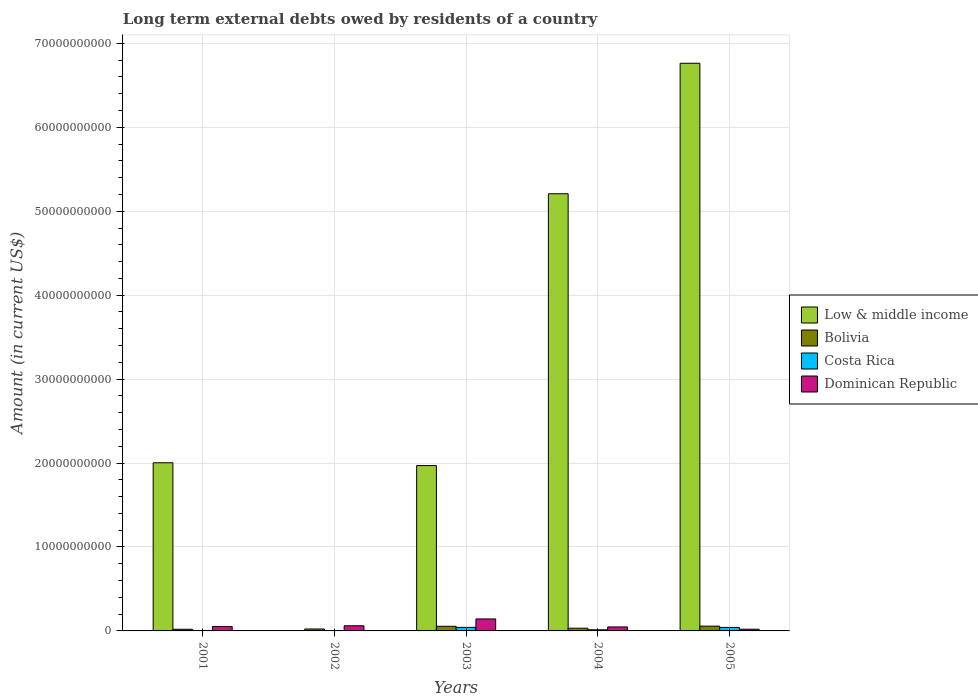How many different coloured bars are there?
Your answer should be very brief. 4. Are the number of bars per tick equal to the number of legend labels?
Your answer should be very brief. No. Are the number of bars on each tick of the X-axis equal?
Make the answer very short. No. What is the label of the 1st group of bars from the left?
Provide a short and direct response. 2001. What is the amount of long-term external debts owed by residents in Bolivia in 2005?
Your response must be concise. 5.71e+08. Across all years, what is the maximum amount of long-term external debts owed by residents in Bolivia?
Your answer should be compact. 5.71e+08. Across all years, what is the minimum amount of long-term external debts owed by residents in Dominican Republic?
Offer a very short reply. 2.03e+08. In which year was the amount of long-term external debts owed by residents in Low & middle income maximum?
Ensure brevity in your answer.  2005. What is the total amount of long-term external debts owed by residents in Bolivia in the graph?
Provide a short and direct response. 1.87e+09. What is the difference between the amount of long-term external debts owed by residents in Dominican Republic in 2001 and that in 2004?
Make the answer very short. 5.07e+07. What is the difference between the amount of long-term external debts owed by residents in Bolivia in 2003 and the amount of long-term external debts owed by residents in Costa Rica in 2004?
Give a very brief answer. 4.18e+08. What is the average amount of long-term external debts owed by residents in Bolivia per year?
Your answer should be very brief. 3.74e+08. In the year 2003, what is the difference between the amount of long-term external debts owed by residents in Low & middle income and amount of long-term external debts owed by residents in Dominican Republic?
Your answer should be very brief. 1.83e+1. What is the ratio of the amount of long-term external debts owed by residents in Low & middle income in 2001 to that in 2004?
Give a very brief answer. 0.38. What is the difference between the highest and the second highest amount of long-term external debts owed by residents in Costa Rica?
Ensure brevity in your answer.  6.95e+06. What is the difference between the highest and the lowest amount of long-term external debts owed by residents in Low & middle income?
Give a very brief answer. 6.76e+1. In how many years, is the amount of long-term external debts owed by residents in Costa Rica greater than the average amount of long-term external debts owed by residents in Costa Rica taken over all years?
Make the answer very short. 2. Is the sum of the amount of long-term external debts owed by residents in Dominican Republic in 2003 and 2004 greater than the maximum amount of long-term external debts owed by residents in Low & middle income across all years?
Your answer should be very brief. No. Is it the case that in every year, the sum of the amount of long-term external debts owed by residents in Bolivia and amount of long-term external debts owed by residents in Costa Rica is greater than the sum of amount of long-term external debts owed by residents in Dominican Republic and amount of long-term external debts owed by residents in Low & middle income?
Ensure brevity in your answer.  No. Are all the bars in the graph horizontal?
Offer a very short reply. No. What is the difference between two consecutive major ticks on the Y-axis?
Offer a terse response. 1.00e+1. Are the values on the major ticks of Y-axis written in scientific E-notation?
Offer a very short reply. No. What is the title of the graph?
Your response must be concise. Long term external debts owed by residents of a country. Does "Europe(all income levels)" appear as one of the legend labels in the graph?
Your answer should be very brief. No. What is the label or title of the X-axis?
Give a very brief answer. Years. What is the Amount (in current US$) in Low & middle income in 2001?
Your answer should be compact. 2.00e+1. What is the Amount (in current US$) in Bolivia in 2001?
Your answer should be very brief. 1.96e+08. What is the Amount (in current US$) in Costa Rica in 2001?
Offer a terse response. 2.68e+07. What is the Amount (in current US$) in Dominican Republic in 2001?
Make the answer very short. 5.24e+08. What is the Amount (in current US$) in Low & middle income in 2002?
Offer a very short reply. 0. What is the Amount (in current US$) of Bolivia in 2002?
Offer a terse response. 2.30e+08. What is the Amount (in current US$) of Costa Rica in 2002?
Keep it short and to the point. 0. What is the Amount (in current US$) in Dominican Republic in 2002?
Provide a short and direct response. 6.15e+08. What is the Amount (in current US$) in Low & middle income in 2003?
Provide a succinct answer. 1.97e+1. What is the Amount (in current US$) of Bolivia in 2003?
Offer a terse response. 5.53e+08. What is the Amount (in current US$) of Costa Rica in 2003?
Provide a succinct answer. 4.24e+08. What is the Amount (in current US$) in Dominican Republic in 2003?
Ensure brevity in your answer.  1.43e+09. What is the Amount (in current US$) in Low & middle income in 2004?
Offer a very short reply. 5.21e+1. What is the Amount (in current US$) of Bolivia in 2004?
Your answer should be compact. 3.22e+08. What is the Amount (in current US$) of Costa Rica in 2004?
Offer a terse response. 1.35e+08. What is the Amount (in current US$) of Dominican Republic in 2004?
Provide a succinct answer. 4.73e+08. What is the Amount (in current US$) of Low & middle income in 2005?
Keep it short and to the point. 6.76e+1. What is the Amount (in current US$) in Bolivia in 2005?
Provide a succinct answer. 5.71e+08. What is the Amount (in current US$) of Costa Rica in 2005?
Ensure brevity in your answer.  4.17e+08. What is the Amount (in current US$) in Dominican Republic in 2005?
Provide a short and direct response. 2.03e+08. Across all years, what is the maximum Amount (in current US$) in Low & middle income?
Keep it short and to the point. 6.76e+1. Across all years, what is the maximum Amount (in current US$) in Bolivia?
Make the answer very short. 5.71e+08. Across all years, what is the maximum Amount (in current US$) of Costa Rica?
Keep it short and to the point. 4.24e+08. Across all years, what is the maximum Amount (in current US$) of Dominican Republic?
Keep it short and to the point. 1.43e+09. Across all years, what is the minimum Amount (in current US$) in Bolivia?
Offer a very short reply. 1.96e+08. Across all years, what is the minimum Amount (in current US$) of Costa Rica?
Your answer should be very brief. 0. Across all years, what is the minimum Amount (in current US$) in Dominican Republic?
Offer a terse response. 2.03e+08. What is the total Amount (in current US$) of Low & middle income in the graph?
Your response must be concise. 1.59e+11. What is the total Amount (in current US$) in Bolivia in the graph?
Your response must be concise. 1.87e+09. What is the total Amount (in current US$) of Costa Rica in the graph?
Your answer should be compact. 1.00e+09. What is the total Amount (in current US$) of Dominican Republic in the graph?
Ensure brevity in your answer.  3.24e+09. What is the difference between the Amount (in current US$) in Bolivia in 2001 and that in 2002?
Keep it short and to the point. -3.35e+07. What is the difference between the Amount (in current US$) of Dominican Republic in 2001 and that in 2002?
Your answer should be very brief. -9.15e+07. What is the difference between the Amount (in current US$) in Low & middle income in 2001 and that in 2003?
Offer a terse response. 3.35e+08. What is the difference between the Amount (in current US$) of Bolivia in 2001 and that in 2003?
Give a very brief answer. -3.56e+08. What is the difference between the Amount (in current US$) in Costa Rica in 2001 and that in 2003?
Offer a very short reply. -3.97e+08. What is the difference between the Amount (in current US$) in Dominican Republic in 2001 and that in 2003?
Provide a short and direct response. -9.02e+08. What is the difference between the Amount (in current US$) of Low & middle income in 2001 and that in 2004?
Your answer should be compact. -3.20e+1. What is the difference between the Amount (in current US$) in Bolivia in 2001 and that in 2004?
Your answer should be compact. -1.26e+08. What is the difference between the Amount (in current US$) of Costa Rica in 2001 and that in 2004?
Ensure brevity in your answer.  -1.08e+08. What is the difference between the Amount (in current US$) in Dominican Republic in 2001 and that in 2004?
Keep it short and to the point. 5.07e+07. What is the difference between the Amount (in current US$) in Low & middle income in 2001 and that in 2005?
Offer a very short reply. -4.76e+1. What is the difference between the Amount (in current US$) in Bolivia in 2001 and that in 2005?
Give a very brief answer. -3.75e+08. What is the difference between the Amount (in current US$) in Costa Rica in 2001 and that in 2005?
Provide a short and direct response. -3.90e+08. What is the difference between the Amount (in current US$) of Dominican Republic in 2001 and that in 2005?
Keep it short and to the point. 3.21e+08. What is the difference between the Amount (in current US$) of Bolivia in 2002 and that in 2003?
Ensure brevity in your answer.  -3.23e+08. What is the difference between the Amount (in current US$) in Dominican Republic in 2002 and that in 2003?
Your answer should be very brief. -8.11e+08. What is the difference between the Amount (in current US$) of Bolivia in 2002 and that in 2004?
Your answer should be compact. -9.23e+07. What is the difference between the Amount (in current US$) in Dominican Republic in 2002 and that in 2004?
Make the answer very short. 1.42e+08. What is the difference between the Amount (in current US$) of Bolivia in 2002 and that in 2005?
Your answer should be very brief. -3.41e+08. What is the difference between the Amount (in current US$) of Dominican Republic in 2002 and that in 2005?
Ensure brevity in your answer.  4.12e+08. What is the difference between the Amount (in current US$) in Low & middle income in 2003 and that in 2004?
Offer a terse response. -3.24e+1. What is the difference between the Amount (in current US$) of Bolivia in 2003 and that in 2004?
Make the answer very short. 2.31e+08. What is the difference between the Amount (in current US$) of Costa Rica in 2003 and that in 2004?
Provide a short and direct response. 2.89e+08. What is the difference between the Amount (in current US$) of Dominican Republic in 2003 and that in 2004?
Provide a short and direct response. 9.53e+08. What is the difference between the Amount (in current US$) in Low & middle income in 2003 and that in 2005?
Keep it short and to the point. -4.79e+1. What is the difference between the Amount (in current US$) in Bolivia in 2003 and that in 2005?
Make the answer very short. -1.83e+07. What is the difference between the Amount (in current US$) in Costa Rica in 2003 and that in 2005?
Provide a succinct answer. 6.95e+06. What is the difference between the Amount (in current US$) of Dominican Republic in 2003 and that in 2005?
Make the answer very short. 1.22e+09. What is the difference between the Amount (in current US$) in Low & middle income in 2004 and that in 2005?
Your answer should be compact. -1.55e+1. What is the difference between the Amount (in current US$) of Bolivia in 2004 and that in 2005?
Offer a terse response. -2.49e+08. What is the difference between the Amount (in current US$) in Costa Rica in 2004 and that in 2005?
Provide a succinct answer. -2.82e+08. What is the difference between the Amount (in current US$) in Dominican Republic in 2004 and that in 2005?
Make the answer very short. 2.70e+08. What is the difference between the Amount (in current US$) of Low & middle income in 2001 and the Amount (in current US$) of Bolivia in 2002?
Your answer should be very brief. 1.98e+1. What is the difference between the Amount (in current US$) in Low & middle income in 2001 and the Amount (in current US$) in Dominican Republic in 2002?
Ensure brevity in your answer.  1.94e+1. What is the difference between the Amount (in current US$) in Bolivia in 2001 and the Amount (in current US$) in Dominican Republic in 2002?
Offer a very short reply. -4.19e+08. What is the difference between the Amount (in current US$) in Costa Rica in 2001 and the Amount (in current US$) in Dominican Republic in 2002?
Your response must be concise. -5.89e+08. What is the difference between the Amount (in current US$) of Low & middle income in 2001 and the Amount (in current US$) of Bolivia in 2003?
Your answer should be compact. 1.95e+1. What is the difference between the Amount (in current US$) of Low & middle income in 2001 and the Amount (in current US$) of Costa Rica in 2003?
Your answer should be very brief. 1.96e+1. What is the difference between the Amount (in current US$) of Low & middle income in 2001 and the Amount (in current US$) of Dominican Republic in 2003?
Keep it short and to the point. 1.86e+1. What is the difference between the Amount (in current US$) in Bolivia in 2001 and the Amount (in current US$) in Costa Rica in 2003?
Make the answer very short. -2.27e+08. What is the difference between the Amount (in current US$) in Bolivia in 2001 and the Amount (in current US$) in Dominican Republic in 2003?
Your answer should be compact. -1.23e+09. What is the difference between the Amount (in current US$) in Costa Rica in 2001 and the Amount (in current US$) in Dominican Republic in 2003?
Give a very brief answer. -1.40e+09. What is the difference between the Amount (in current US$) in Low & middle income in 2001 and the Amount (in current US$) in Bolivia in 2004?
Your answer should be very brief. 1.97e+1. What is the difference between the Amount (in current US$) in Low & middle income in 2001 and the Amount (in current US$) in Costa Rica in 2004?
Keep it short and to the point. 1.99e+1. What is the difference between the Amount (in current US$) in Low & middle income in 2001 and the Amount (in current US$) in Dominican Republic in 2004?
Make the answer very short. 1.96e+1. What is the difference between the Amount (in current US$) in Bolivia in 2001 and the Amount (in current US$) in Costa Rica in 2004?
Offer a terse response. 6.14e+07. What is the difference between the Amount (in current US$) of Bolivia in 2001 and the Amount (in current US$) of Dominican Republic in 2004?
Give a very brief answer. -2.77e+08. What is the difference between the Amount (in current US$) of Costa Rica in 2001 and the Amount (in current US$) of Dominican Republic in 2004?
Offer a very short reply. -4.46e+08. What is the difference between the Amount (in current US$) in Low & middle income in 2001 and the Amount (in current US$) in Bolivia in 2005?
Give a very brief answer. 1.95e+1. What is the difference between the Amount (in current US$) of Low & middle income in 2001 and the Amount (in current US$) of Costa Rica in 2005?
Your answer should be compact. 1.96e+1. What is the difference between the Amount (in current US$) of Low & middle income in 2001 and the Amount (in current US$) of Dominican Republic in 2005?
Offer a terse response. 1.98e+1. What is the difference between the Amount (in current US$) of Bolivia in 2001 and the Amount (in current US$) of Costa Rica in 2005?
Give a very brief answer. -2.20e+08. What is the difference between the Amount (in current US$) in Bolivia in 2001 and the Amount (in current US$) in Dominican Republic in 2005?
Keep it short and to the point. -6.85e+06. What is the difference between the Amount (in current US$) of Costa Rica in 2001 and the Amount (in current US$) of Dominican Republic in 2005?
Keep it short and to the point. -1.76e+08. What is the difference between the Amount (in current US$) of Bolivia in 2002 and the Amount (in current US$) of Costa Rica in 2003?
Give a very brief answer. -1.94e+08. What is the difference between the Amount (in current US$) of Bolivia in 2002 and the Amount (in current US$) of Dominican Republic in 2003?
Offer a terse response. -1.20e+09. What is the difference between the Amount (in current US$) of Bolivia in 2002 and the Amount (in current US$) of Costa Rica in 2004?
Keep it short and to the point. 9.50e+07. What is the difference between the Amount (in current US$) in Bolivia in 2002 and the Amount (in current US$) in Dominican Republic in 2004?
Ensure brevity in your answer.  -2.43e+08. What is the difference between the Amount (in current US$) in Bolivia in 2002 and the Amount (in current US$) in Costa Rica in 2005?
Make the answer very short. -1.87e+08. What is the difference between the Amount (in current US$) of Bolivia in 2002 and the Amount (in current US$) of Dominican Republic in 2005?
Your answer should be compact. 2.67e+07. What is the difference between the Amount (in current US$) in Low & middle income in 2003 and the Amount (in current US$) in Bolivia in 2004?
Provide a short and direct response. 1.94e+1. What is the difference between the Amount (in current US$) in Low & middle income in 2003 and the Amount (in current US$) in Costa Rica in 2004?
Offer a terse response. 1.96e+1. What is the difference between the Amount (in current US$) of Low & middle income in 2003 and the Amount (in current US$) of Dominican Republic in 2004?
Offer a terse response. 1.92e+1. What is the difference between the Amount (in current US$) of Bolivia in 2003 and the Amount (in current US$) of Costa Rica in 2004?
Offer a very short reply. 4.18e+08. What is the difference between the Amount (in current US$) in Bolivia in 2003 and the Amount (in current US$) in Dominican Republic in 2004?
Offer a very short reply. 7.94e+07. What is the difference between the Amount (in current US$) in Costa Rica in 2003 and the Amount (in current US$) in Dominican Republic in 2004?
Provide a succinct answer. -4.96e+07. What is the difference between the Amount (in current US$) of Low & middle income in 2003 and the Amount (in current US$) of Bolivia in 2005?
Your answer should be compact. 1.91e+1. What is the difference between the Amount (in current US$) of Low & middle income in 2003 and the Amount (in current US$) of Costa Rica in 2005?
Your answer should be compact. 1.93e+1. What is the difference between the Amount (in current US$) in Low & middle income in 2003 and the Amount (in current US$) in Dominican Republic in 2005?
Offer a very short reply. 1.95e+1. What is the difference between the Amount (in current US$) in Bolivia in 2003 and the Amount (in current US$) in Costa Rica in 2005?
Make the answer very short. 1.36e+08. What is the difference between the Amount (in current US$) in Bolivia in 2003 and the Amount (in current US$) in Dominican Republic in 2005?
Keep it short and to the point. 3.50e+08. What is the difference between the Amount (in current US$) in Costa Rica in 2003 and the Amount (in current US$) in Dominican Republic in 2005?
Your answer should be compact. 2.21e+08. What is the difference between the Amount (in current US$) in Low & middle income in 2004 and the Amount (in current US$) in Bolivia in 2005?
Your answer should be very brief. 5.15e+1. What is the difference between the Amount (in current US$) in Low & middle income in 2004 and the Amount (in current US$) in Costa Rica in 2005?
Your answer should be compact. 5.17e+1. What is the difference between the Amount (in current US$) of Low & middle income in 2004 and the Amount (in current US$) of Dominican Republic in 2005?
Ensure brevity in your answer.  5.19e+1. What is the difference between the Amount (in current US$) of Bolivia in 2004 and the Amount (in current US$) of Costa Rica in 2005?
Offer a very short reply. -9.45e+07. What is the difference between the Amount (in current US$) in Bolivia in 2004 and the Amount (in current US$) in Dominican Republic in 2005?
Keep it short and to the point. 1.19e+08. What is the difference between the Amount (in current US$) of Costa Rica in 2004 and the Amount (in current US$) of Dominican Republic in 2005?
Your answer should be compact. -6.83e+07. What is the average Amount (in current US$) in Low & middle income per year?
Provide a short and direct response. 3.19e+1. What is the average Amount (in current US$) of Bolivia per year?
Offer a terse response. 3.74e+08. What is the average Amount (in current US$) in Costa Rica per year?
Ensure brevity in your answer.  2.00e+08. What is the average Amount (in current US$) in Dominican Republic per year?
Provide a short and direct response. 6.48e+08. In the year 2001, what is the difference between the Amount (in current US$) of Low & middle income and Amount (in current US$) of Bolivia?
Provide a short and direct response. 1.98e+1. In the year 2001, what is the difference between the Amount (in current US$) in Low & middle income and Amount (in current US$) in Costa Rica?
Provide a succinct answer. 2.00e+1. In the year 2001, what is the difference between the Amount (in current US$) of Low & middle income and Amount (in current US$) of Dominican Republic?
Make the answer very short. 1.95e+1. In the year 2001, what is the difference between the Amount (in current US$) of Bolivia and Amount (in current US$) of Costa Rica?
Provide a succinct answer. 1.69e+08. In the year 2001, what is the difference between the Amount (in current US$) of Bolivia and Amount (in current US$) of Dominican Republic?
Your answer should be very brief. -3.28e+08. In the year 2001, what is the difference between the Amount (in current US$) of Costa Rica and Amount (in current US$) of Dominican Republic?
Offer a very short reply. -4.97e+08. In the year 2002, what is the difference between the Amount (in current US$) in Bolivia and Amount (in current US$) in Dominican Republic?
Give a very brief answer. -3.86e+08. In the year 2003, what is the difference between the Amount (in current US$) in Low & middle income and Amount (in current US$) in Bolivia?
Your answer should be compact. 1.91e+1. In the year 2003, what is the difference between the Amount (in current US$) in Low & middle income and Amount (in current US$) in Costa Rica?
Offer a terse response. 1.93e+1. In the year 2003, what is the difference between the Amount (in current US$) in Low & middle income and Amount (in current US$) in Dominican Republic?
Keep it short and to the point. 1.83e+1. In the year 2003, what is the difference between the Amount (in current US$) of Bolivia and Amount (in current US$) of Costa Rica?
Make the answer very short. 1.29e+08. In the year 2003, what is the difference between the Amount (in current US$) of Bolivia and Amount (in current US$) of Dominican Republic?
Offer a very short reply. -8.74e+08. In the year 2003, what is the difference between the Amount (in current US$) in Costa Rica and Amount (in current US$) in Dominican Republic?
Provide a succinct answer. -1.00e+09. In the year 2004, what is the difference between the Amount (in current US$) in Low & middle income and Amount (in current US$) in Bolivia?
Offer a very short reply. 5.18e+1. In the year 2004, what is the difference between the Amount (in current US$) of Low & middle income and Amount (in current US$) of Costa Rica?
Your answer should be compact. 5.19e+1. In the year 2004, what is the difference between the Amount (in current US$) in Low & middle income and Amount (in current US$) in Dominican Republic?
Your answer should be compact. 5.16e+1. In the year 2004, what is the difference between the Amount (in current US$) of Bolivia and Amount (in current US$) of Costa Rica?
Your answer should be compact. 1.87e+08. In the year 2004, what is the difference between the Amount (in current US$) of Bolivia and Amount (in current US$) of Dominican Republic?
Provide a succinct answer. -1.51e+08. In the year 2004, what is the difference between the Amount (in current US$) in Costa Rica and Amount (in current US$) in Dominican Republic?
Your answer should be very brief. -3.38e+08. In the year 2005, what is the difference between the Amount (in current US$) of Low & middle income and Amount (in current US$) of Bolivia?
Make the answer very short. 6.71e+1. In the year 2005, what is the difference between the Amount (in current US$) in Low & middle income and Amount (in current US$) in Costa Rica?
Ensure brevity in your answer.  6.72e+1. In the year 2005, what is the difference between the Amount (in current US$) of Low & middle income and Amount (in current US$) of Dominican Republic?
Your response must be concise. 6.74e+1. In the year 2005, what is the difference between the Amount (in current US$) in Bolivia and Amount (in current US$) in Costa Rica?
Provide a succinct answer. 1.54e+08. In the year 2005, what is the difference between the Amount (in current US$) of Bolivia and Amount (in current US$) of Dominican Republic?
Offer a very short reply. 3.68e+08. In the year 2005, what is the difference between the Amount (in current US$) of Costa Rica and Amount (in current US$) of Dominican Republic?
Your answer should be compact. 2.14e+08. What is the ratio of the Amount (in current US$) in Bolivia in 2001 to that in 2002?
Offer a terse response. 0.85. What is the ratio of the Amount (in current US$) of Dominican Republic in 2001 to that in 2002?
Offer a terse response. 0.85. What is the ratio of the Amount (in current US$) of Bolivia in 2001 to that in 2003?
Your response must be concise. 0.36. What is the ratio of the Amount (in current US$) of Costa Rica in 2001 to that in 2003?
Your response must be concise. 0.06. What is the ratio of the Amount (in current US$) of Dominican Republic in 2001 to that in 2003?
Your response must be concise. 0.37. What is the ratio of the Amount (in current US$) in Low & middle income in 2001 to that in 2004?
Make the answer very short. 0.38. What is the ratio of the Amount (in current US$) in Bolivia in 2001 to that in 2004?
Provide a short and direct response. 0.61. What is the ratio of the Amount (in current US$) of Costa Rica in 2001 to that in 2004?
Your answer should be compact. 0.2. What is the ratio of the Amount (in current US$) in Dominican Republic in 2001 to that in 2004?
Your answer should be very brief. 1.11. What is the ratio of the Amount (in current US$) of Low & middle income in 2001 to that in 2005?
Offer a very short reply. 0.3. What is the ratio of the Amount (in current US$) in Bolivia in 2001 to that in 2005?
Ensure brevity in your answer.  0.34. What is the ratio of the Amount (in current US$) of Costa Rica in 2001 to that in 2005?
Provide a succinct answer. 0.06. What is the ratio of the Amount (in current US$) of Dominican Republic in 2001 to that in 2005?
Your response must be concise. 2.58. What is the ratio of the Amount (in current US$) in Bolivia in 2002 to that in 2003?
Your response must be concise. 0.42. What is the ratio of the Amount (in current US$) in Dominican Republic in 2002 to that in 2003?
Your response must be concise. 0.43. What is the ratio of the Amount (in current US$) of Bolivia in 2002 to that in 2004?
Your answer should be compact. 0.71. What is the ratio of the Amount (in current US$) of Dominican Republic in 2002 to that in 2004?
Provide a short and direct response. 1.3. What is the ratio of the Amount (in current US$) of Bolivia in 2002 to that in 2005?
Provide a succinct answer. 0.4. What is the ratio of the Amount (in current US$) in Dominican Republic in 2002 to that in 2005?
Give a very brief answer. 3.03. What is the ratio of the Amount (in current US$) in Low & middle income in 2003 to that in 2004?
Give a very brief answer. 0.38. What is the ratio of the Amount (in current US$) of Bolivia in 2003 to that in 2004?
Give a very brief answer. 1.72. What is the ratio of the Amount (in current US$) of Costa Rica in 2003 to that in 2004?
Provide a short and direct response. 3.14. What is the ratio of the Amount (in current US$) in Dominican Republic in 2003 to that in 2004?
Offer a terse response. 3.01. What is the ratio of the Amount (in current US$) of Low & middle income in 2003 to that in 2005?
Provide a succinct answer. 0.29. What is the ratio of the Amount (in current US$) in Bolivia in 2003 to that in 2005?
Your response must be concise. 0.97. What is the ratio of the Amount (in current US$) of Costa Rica in 2003 to that in 2005?
Offer a very short reply. 1.02. What is the ratio of the Amount (in current US$) of Dominican Republic in 2003 to that in 2005?
Your response must be concise. 7.02. What is the ratio of the Amount (in current US$) of Low & middle income in 2004 to that in 2005?
Give a very brief answer. 0.77. What is the ratio of the Amount (in current US$) in Bolivia in 2004 to that in 2005?
Make the answer very short. 0.56. What is the ratio of the Amount (in current US$) of Costa Rica in 2004 to that in 2005?
Give a very brief answer. 0.32. What is the ratio of the Amount (in current US$) in Dominican Republic in 2004 to that in 2005?
Give a very brief answer. 2.33. What is the difference between the highest and the second highest Amount (in current US$) of Low & middle income?
Offer a very short reply. 1.55e+1. What is the difference between the highest and the second highest Amount (in current US$) of Bolivia?
Your answer should be compact. 1.83e+07. What is the difference between the highest and the second highest Amount (in current US$) of Costa Rica?
Offer a very short reply. 6.95e+06. What is the difference between the highest and the second highest Amount (in current US$) in Dominican Republic?
Your answer should be compact. 8.11e+08. What is the difference between the highest and the lowest Amount (in current US$) in Low & middle income?
Your answer should be compact. 6.76e+1. What is the difference between the highest and the lowest Amount (in current US$) in Bolivia?
Provide a succinct answer. 3.75e+08. What is the difference between the highest and the lowest Amount (in current US$) of Costa Rica?
Provide a succinct answer. 4.24e+08. What is the difference between the highest and the lowest Amount (in current US$) in Dominican Republic?
Give a very brief answer. 1.22e+09. 